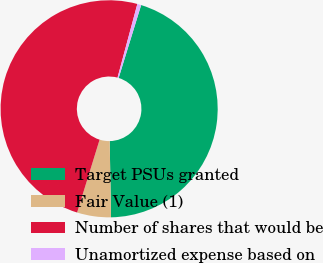Convert chart to OTSL. <chart><loc_0><loc_0><loc_500><loc_500><pie_chart><fcel>Target PSUs granted<fcel>Fair Value (1)<fcel>Number of shares that would be<fcel>Unamortized expense based on<nl><fcel>44.96%<fcel>5.04%<fcel>49.42%<fcel>0.58%<nl></chart> 